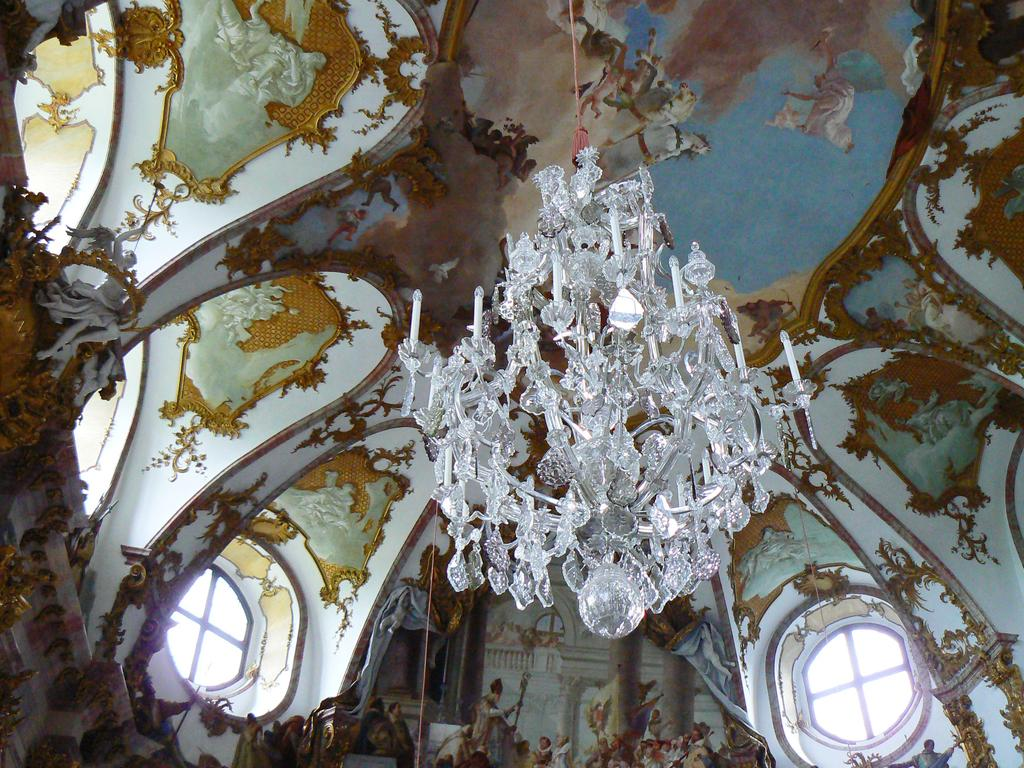What type of location is depicted in the image? The image is an inside view of a building. What type of lighting is present in the image? There are ceiling lights in the image. What type of decorations can be seen in the background of the image? There are paintings in the background of the image. What architectural feature is present on the wall in the image? There are windows on the wall in the image. Can you hear the person in the image crying? There is no person present in the image, and therefore no crying can be heard. 